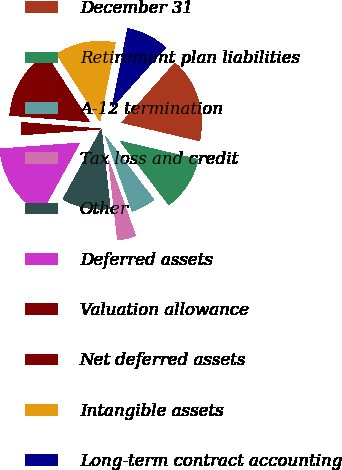Convert chart. <chart><loc_0><loc_0><loc_500><loc_500><pie_chart><fcel>December 31<fcel>Retirement plan liabilities<fcel>A-12 termination<fcel>Tax loss and credit<fcel>Other<fcel>Deferred assets<fcel>Valuation allowance<fcel>Net deferred assets<fcel>Intangible assets<fcel>Long-term contract accounting<nl><fcel>17.04%<fcel>10.97%<fcel>4.9%<fcel>3.69%<fcel>9.76%<fcel>15.83%<fcel>2.47%<fcel>14.61%<fcel>12.19%<fcel>8.54%<nl></chart> 